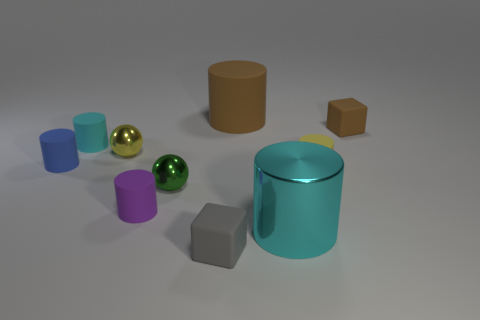Subtract all large cyan cylinders. How many cylinders are left? 5 Subtract all purple cylinders. How many cylinders are left? 5 Subtract all red cylinders. Subtract all gray balls. How many cylinders are left? 6 Subtract all cubes. How many objects are left? 8 Add 7 matte cubes. How many matte cubes exist? 9 Subtract 0 gray spheres. How many objects are left? 10 Subtract all rubber cubes. Subtract all small things. How many objects are left? 0 Add 8 yellow cylinders. How many yellow cylinders are left? 9 